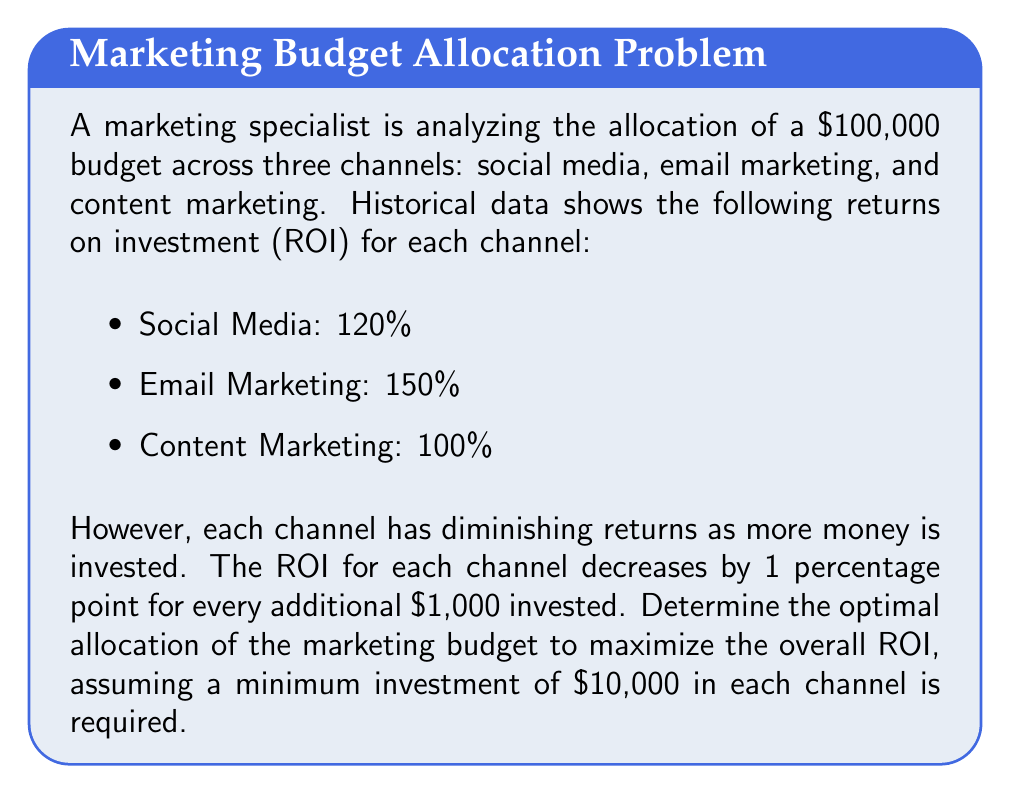What is the answer to this math problem? To solve this problem, we need to use optimization techniques. Let's approach this step-by-step:

1) Let $x$, $y$, and $z$ represent the investment in thousands of dollars for social media, email marketing, and content marketing respectively.

2) The ROI functions for each channel can be expressed as:
   
   Social Media: $f(x) = (1.20 - 0.001x)x$
   Email Marketing: $g(y) = (1.50 - 0.001y)y$
   Content Marketing: $h(z) = (1.00 - 0.001z)z$

3) Our objective is to maximize the total return:

   $$\text{Max } R = f(x) + g(y) + h(z)$$

4) Subject to the constraints:
   
   $x + y + z = 100$ (total budget constraint)
   $x \geq 10$, $y \geq 10$, $z \geq 10$ (minimum investment constraints)

5) To find the optimal solution, we can use the method of Lagrange multipliers. The Lagrangian function is:

   $$L = f(x) + g(y) + h(z) - \lambda(x + y + z - 100)$$

6) Taking partial derivatives and setting them to zero:

   $$\frac{\partial L}{\partial x} = 1.20 - 0.002x - \lambda = 0$$
   $$\frac{\partial L}{\partial y} = 1.50 - 0.002y - \lambda = 0$$
   $$\frac{\partial L}{\partial z} = 1.00 - 0.002z - \lambda = 0$$

7) From these equations, we can derive:

   $x = 600 - 500\lambda$
   $y = 750 - 500\lambda$
   $z = 500 - 500\lambda$

8) Substituting these into the budget constraint:

   $(600 - 500\lambda) + (750 - 500\lambda) + (500 - 500\lambda) = 100$
   $1850 - 1500\lambda = 100$
   $\lambda = 1.1667$

9) Substituting this value of $\lambda$ back:

   $x = 16.67$, $y = 166.67$, $z = -83.33$

10) However, this violates our minimum investment constraint for $z$. Therefore, we need to set $z = 10$ and recalculate $x$ and $y$.

11) With $z = 10$, we have $x + y = 90$. Solving the equations:

    $1.20 - 0.002x = 1.50 - 0.002y$
    $y = 165 - x$
    
    Substituting:
    $1.20 - 0.002x = 1.50 - 0.002(165 - x)$
    $x = 47.5$
    $y = 42.5$

12) Therefore, the optimal allocation is:
    Social Media: $47,500
    Email Marketing: $42,500
    Content Marketing: $10,000

13) The total ROI can be calculated as:
    $R = (1.20 - 0.001*47.5)*47.5 + (1.50 - 0.001*42.5)*42.5 + (1.00 - 0.001*10)*10 = 56.81 + 63.28 + 9.9 = 129.99$

    The overall ROI is $(129,990 / 100,000) * 100\% = 129.99\%$
Answer: The optimal allocation of the marketing budget is:
Social Media: $47,500
Email Marketing: $42,500
Content Marketing: $10,000

This allocation yields a maximum overall ROI of 129.99%. 